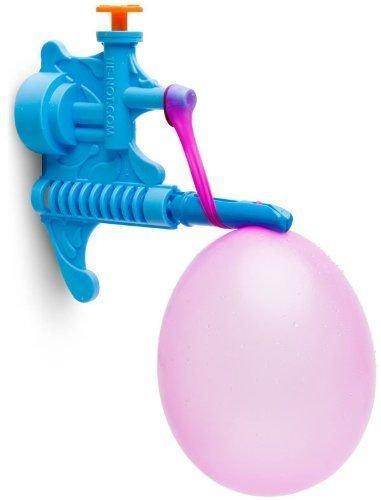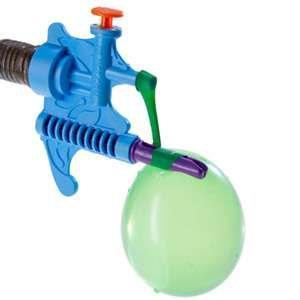The first image is the image on the left, the second image is the image on the right. For the images displayed, is the sentence "Only animal-shaped balloon animals are shown." factually correct? Answer yes or no. No. 